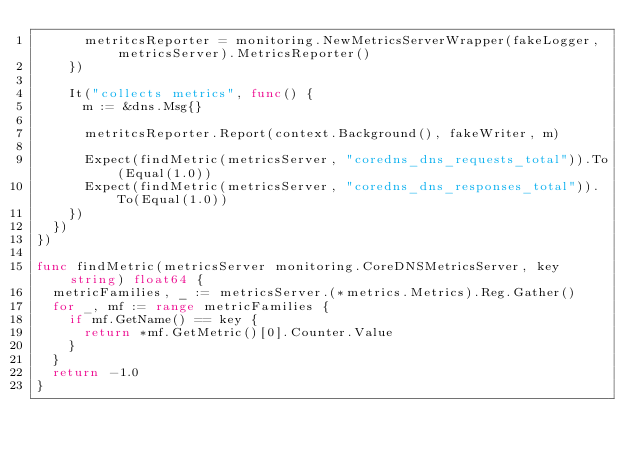Convert code to text. <code><loc_0><loc_0><loc_500><loc_500><_Go_>			metritcsReporter = monitoring.NewMetricsServerWrapper(fakeLogger, metricsServer).MetricsReporter()
		})

		It("collects metrics", func() {
			m := &dns.Msg{}

			metritcsReporter.Report(context.Background(), fakeWriter, m)

			Expect(findMetric(metricsServer, "coredns_dns_requests_total")).To(Equal(1.0))
			Expect(findMetric(metricsServer, "coredns_dns_responses_total")).To(Equal(1.0))
		})
	})
})

func findMetric(metricsServer monitoring.CoreDNSMetricsServer, key string) float64 {
	metricFamilies, _ := metricsServer.(*metrics.Metrics).Reg.Gather()
	for _, mf := range metricFamilies {
		if mf.GetName() == key {
			return *mf.GetMetric()[0].Counter.Value
		}
	}
	return -1.0
}
</code> 